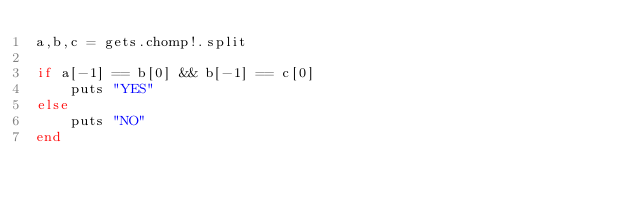Convert code to text. <code><loc_0><loc_0><loc_500><loc_500><_Ruby_>a,b,c = gets.chomp!.split

if a[-1] == b[0] && b[-1] == c[0]
    puts "YES"
else
    puts "NO"
end</code> 